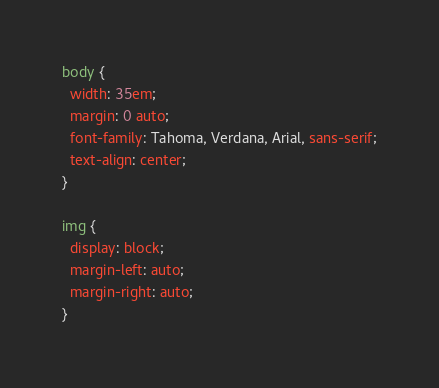<code> <loc_0><loc_0><loc_500><loc_500><_CSS_>body {
  width: 35em;
  margin: 0 auto;
  font-family: Tahoma, Verdana, Arial, sans-serif;
  text-align: center;
}

img {
  display: block;
  margin-left: auto;
  margin-right: auto;
}
</code> 